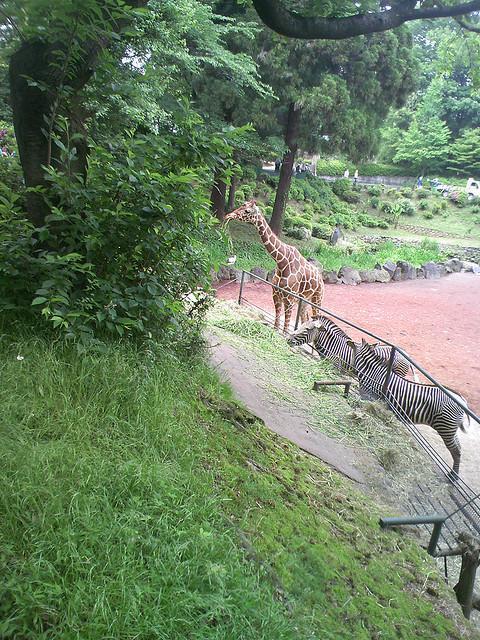How many zebras are there?
Give a very brief answer. 2. How many zebras can you see?
Give a very brief answer. 2. 